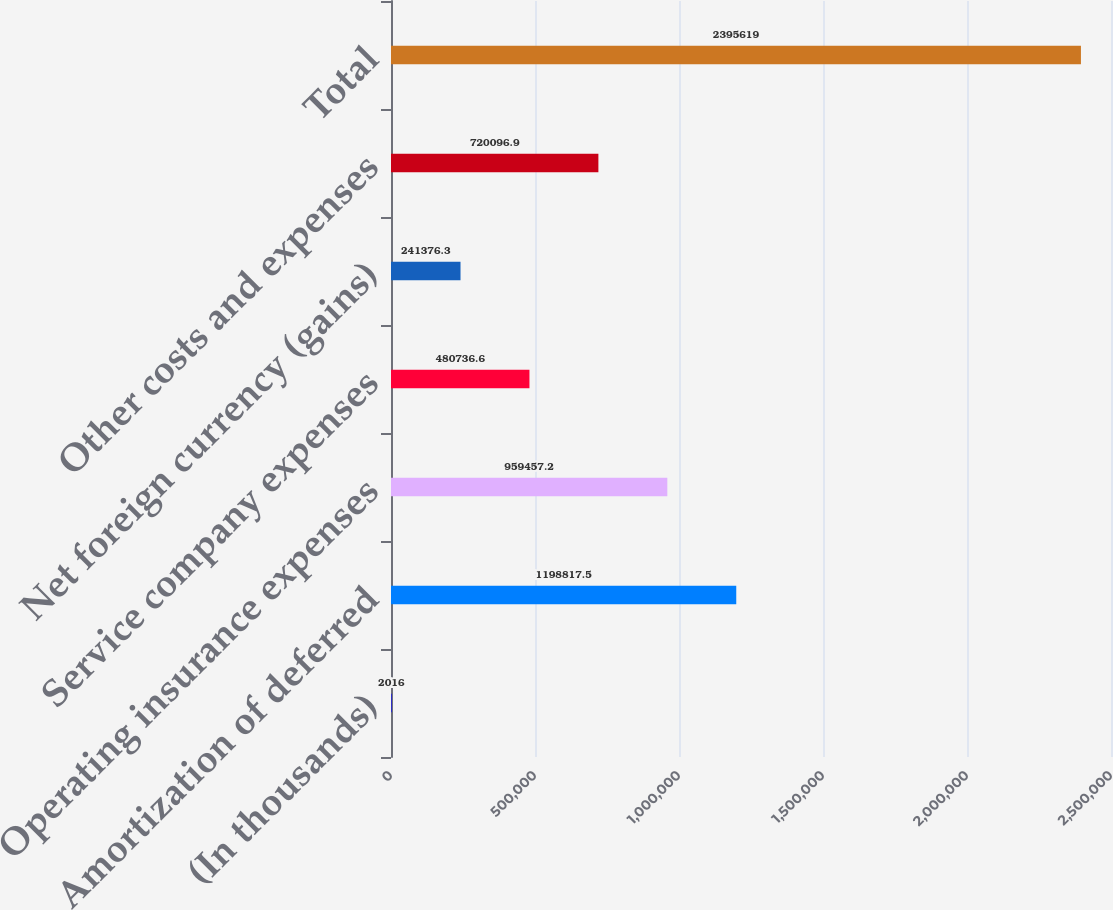Convert chart to OTSL. <chart><loc_0><loc_0><loc_500><loc_500><bar_chart><fcel>(In thousands)<fcel>Amortization of deferred<fcel>Operating insurance expenses<fcel>Service company expenses<fcel>Net foreign currency (gains)<fcel>Other costs and expenses<fcel>Total<nl><fcel>2016<fcel>1.19882e+06<fcel>959457<fcel>480737<fcel>241376<fcel>720097<fcel>2.39562e+06<nl></chart> 